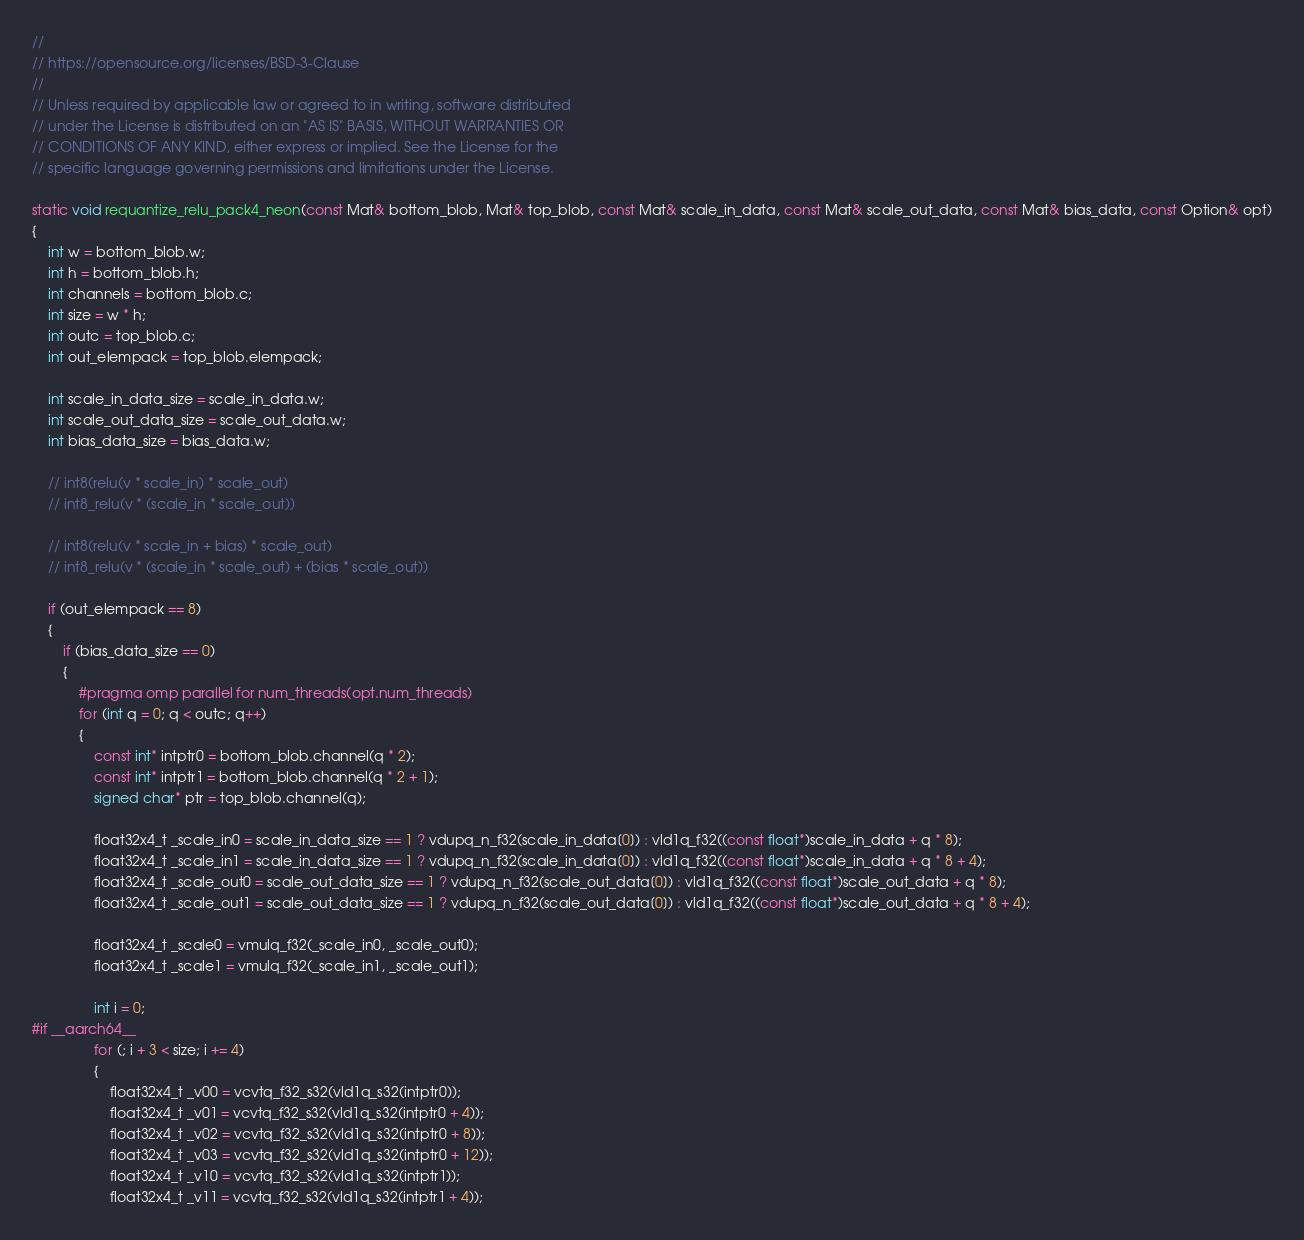Convert code to text. <code><loc_0><loc_0><loc_500><loc_500><_C_>//
// https://opensource.org/licenses/BSD-3-Clause
//
// Unless required by applicable law or agreed to in writing, software distributed
// under the License is distributed on an "AS IS" BASIS, WITHOUT WARRANTIES OR
// CONDITIONS OF ANY KIND, either express or implied. See the License for the
// specific language governing permissions and limitations under the License.

static void requantize_relu_pack4_neon(const Mat& bottom_blob, Mat& top_blob, const Mat& scale_in_data, const Mat& scale_out_data, const Mat& bias_data, const Option& opt)
{
    int w = bottom_blob.w;
    int h = bottom_blob.h;
    int channels = bottom_blob.c;
    int size = w * h;
    int outc = top_blob.c;
    int out_elempack = top_blob.elempack;

    int scale_in_data_size = scale_in_data.w;
    int scale_out_data_size = scale_out_data.w;
    int bias_data_size = bias_data.w;

    // int8(relu(v * scale_in) * scale_out)
    // int8_relu(v * (scale_in * scale_out))

    // int8(relu(v * scale_in + bias) * scale_out)
    // int8_relu(v * (scale_in * scale_out) + (bias * scale_out))

    if (out_elempack == 8)
    {
        if (bias_data_size == 0)
        {
            #pragma omp parallel for num_threads(opt.num_threads)
            for (int q = 0; q < outc; q++)
            {
                const int* intptr0 = bottom_blob.channel(q * 2);
                const int* intptr1 = bottom_blob.channel(q * 2 + 1);
                signed char* ptr = top_blob.channel(q);

                float32x4_t _scale_in0 = scale_in_data_size == 1 ? vdupq_n_f32(scale_in_data[0]) : vld1q_f32((const float*)scale_in_data + q * 8);
                float32x4_t _scale_in1 = scale_in_data_size == 1 ? vdupq_n_f32(scale_in_data[0]) : vld1q_f32((const float*)scale_in_data + q * 8 + 4);
                float32x4_t _scale_out0 = scale_out_data_size == 1 ? vdupq_n_f32(scale_out_data[0]) : vld1q_f32((const float*)scale_out_data + q * 8);
                float32x4_t _scale_out1 = scale_out_data_size == 1 ? vdupq_n_f32(scale_out_data[0]) : vld1q_f32((const float*)scale_out_data + q * 8 + 4);

                float32x4_t _scale0 = vmulq_f32(_scale_in0, _scale_out0);
                float32x4_t _scale1 = vmulq_f32(_scale_in1, _scale_out1);

                int i = 0;
#if __aarch64__
                for (; i + 3 < size; i += 4)
                {
                    float32x4_t _v00 = vcvtq_f32_s32(vld1q_s32(intptr0));
                    float32x4_t _v01 = vcvtq_f32_s32(vld1q_s32(intptr0 + 4));
                    float32x4_t _v02 = vcvtq_f32_s32(vld1q_s32(intptr0 + 8));
                    float32x4_t _v03 = vcvtq_f32_s32(vld1q_s32(intptr0 + 12));
                    float32x4_t _v10 = vcvtq_f32_s32(vld1q_s32(intptr1));
                    float32x4_t _v11 = vcvtq_f32_s32(vld1q_s32(intptr1 + 4));</code> 